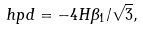Convert formula to latex. <formula><loc_0><loc_0><loc_500><loc_500>\ h p d = - 4 H \beta _ { 1 } / \sqrt { 3 } ,</formula> 